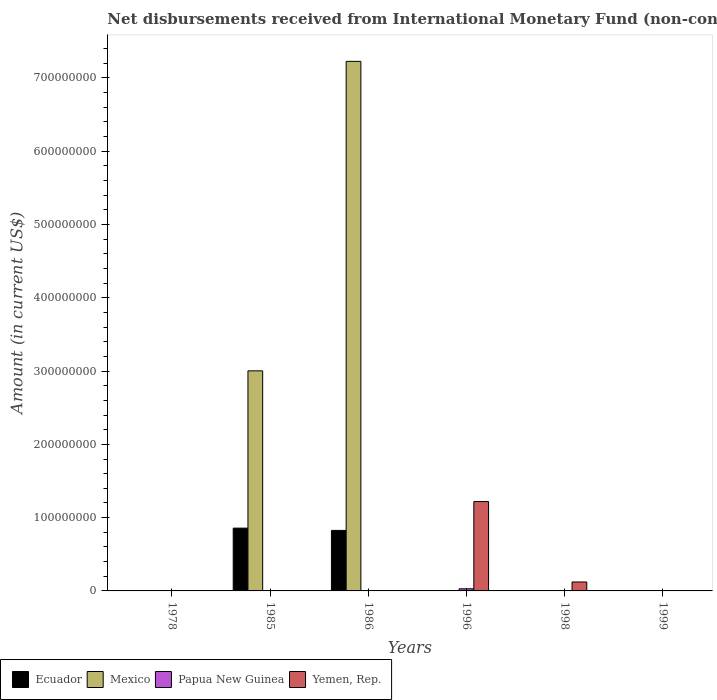How many different coloured bars are there?
Your answer should be very brief. 4. Are the number of bars per tick equal to the number of legend labels?
Make the answer very short. No. Are the number of bars on each tick of the X-axis equal?
Ensure brevity in your answer.  No. How many bars are there on the 4th tick from the left?
Give a very brief answer. 2. What is the label of the 2nd group of bars from the left?
Your response must be concise. 1985. What is the amount of disbursements received from International Monetary Fund in Yemen, Rep. in 1986?
Your answer should be very brief. 0. Across all years, what is the maximum amount of disbursements received from International Monetary Fund in Mexico?
Provide a short and direct response. 7.23e+08. Across all years, what is the minimum amount of disbursements received from International Monetary Fund in Papua New Guinea?
Provide a short and direct response. 0. What is the total amount of disbursements received from International Monetary Fund in Mexico in the graph?
Your answer should be very brief. 1.02e+09. What is the difference between the amount of disbursements received from International Monetary Fund in Ecuador in 1985 and that in 1986?
Offer a very short reply. 3.12e+06. What is the difference between the amount of disbursements received from International Monetary Fund in Papua New Guinea in 1998 and the amount of disbursements received from International Monetary Fund in Yemen, Rep. in 1996?
Your answer should be compact. -1.22e+08. What is the average amount of disbursements received from International Monetary Fund in Papua New Guinea per year?
Make the answer very short. 4.84e+05. In the year 1996, what is the difference between the amount of disbursements received from International Monetary Fund in Papua New Guinea and amount of disbursements received from International Monetary Fund in Yemen, Rep.?
Your response must be concise. -1.19e+08. What is the difference between the highest and the lowest amount of disbursements received from International Monetary Fund in Papua New Guinea?
Your answer should be very brief. 2.90e+06. In how many years, is the amount of disbursements received from International Monetary Fund in Papua New Guinea greater than the average amount of disbursements received from International Monetary Fund in Papua New Guinea taken over all years?
Give a very brief answer. 1. Is it the case that in every year, the sum of the amount of disbursements received from International Monetary Fund in Mexico and amount of disbursements received from International Monetary Fund in Ecuador is greater than the amount of disbursements received from International Monetary Fund in Papua New Guinea?
Keep it short and to the point. No. How many bars are there?
Your response must be concise. 7. How many years are there in the graph?
Make the answer very short. 6. What is the difference between two consecutive major ticks on the Y-axis?
Provide a short and direct response. 1.00e+08. Does the graph contain grids?
Give a very brief answer. No. Where does the legend appear in the graph?
Offer a very short reply. Bottom left. How many legend labels are there?
Your response must be concise. 4. What is the title of the graph?
Ensure brevity in your answer.  Net disbursements received from International Monetary Fund (non-concessional). Does "Netherlands" appear as one of the legend labels in the graph?
Provide a succinct answer. No. What is the Amount (in current US$) in Mexico in 1978?
Keep it short and to the point. 0. What is the Amount (in current US$) in Papua New Guinea in 1978?
Offer a very short reply. 0. What is the Amount (in current US$) in Ecuador in 1985?
Keep it short and to the point. 8.57e+07. What is the Amount (in current US$) in Mexico in 1985?
Provide a succinct answer. 3.00e+08. What is the Amount (in current US$) of Ecuador in 1986?
Give a very brief answer. 8.26e+07. What is the Amount (in current US$) of Mexico in 1986?
Provide a succinct answer. 7.23e+08. What is the Amount (in current US$) in Papua New Guinea in 1996?
Keep it short and to the point. 2.90e+06. What is the Amount (in current US$) of Yemen, Rep. in 1996?
Offer a terse response. 1.22e+08. What is the Amount (in current US$) of Mexico in 1998?
Your response must be concise. 0. What is the Amount (in current US$) in Yemen, Rep. in 1998?
Your response must be concise. 1.22e+07. What is the Amount (in current US$) in Ecuador in 1999?
Your answer should be very brief. 0. What is the Amount (in current US$) of Mexico in 1999?
Keep it short and to the point. 0. Across all years, what is the maximum Amount (in current US$) of Ecuador?
Provide a succinct answer. 8.57e+07. Across all years, what is the maximum Amount (in current US$) in Mexico?
Provide a succinct answer. 7.23e+08. Across all years, what is the maximum Amount (in current US$) of Papua New Guinea?
Offer a very short reply. 2.90e+06. Across all years, what is the maximum Amount (in current US$) of Yemen, Rep.?
Offer a very short reply. 1.22e+08. Across all years, what is the minimum Amount (in current US$) in Yemen, Rep.?
Your answer should be very brief. 0. What is the total Amount (in current US$) of Ecuador in the graph?
Provide a short and direct response. 1.68e+08. What is the total Amount (in current US$) of Mexico in the graph?
Your answer should be very brief. 1.02e+09. What is the total Amount (in current US$) in Papua New Guinea in the graph?
Your answer should be very brief. 2.90e+06. What is the total Amount (in current US$) of Yemen, Rep. in the graph?
Give a very brief answer. 1.34e+08. What is the difference between the Amount (in current US$) in Ecuador in 1985 and that in 1986?
Offer a very short reply. 3.12e+06. What is the difference between the Amount (in current US$) of Mexico in 1985 and that in 1986?
Offer a terse response. -4.22e+08. What is the difference between the Amount (in current US$) of Yemen, Rep. in 1996 and that in 1998?
Provide a succinct answer. 1.10e+08. What is the difference between the Amount (in current US$) of Ecuador in 1985 and the Amount (in current US$) of Mexico in 1986?
Your response must be concise. -6.37e+08. What is the difference between the Amount (in current US$) of Ecuador in 1985 and the Amount (in current US$) of Papua New Guinea in 1996?
Offer a terse response. 8.28e+07. What is the difference between the Amount (in current US$) in Ecuador in 1985 and the Amount (in current US$) in Yemen, Rep. in 1996?
Your response must be concise. -3.63e+07. What is the difference between the Amount (in current US$) of Mexico in 1985 and the Amount (in current US$) of Papua New Guinea in 1996?
Your answer should be very brief. 2.97e+08. What is the difference between the Amount (in current US$) in Mexico in 1985 and the Amount (in current US$) in Yemen, Rep. in 1996?
Your answer should be very brief. 1.78e+08. What is the difference between the Amount (in current US$) in Ecuador in 1985 and the Amount (in current US$) in Yemen, Rep. in 1998?
Offer a very short reply. 7.35e+07. What is the difference between the Amount (in current US$) in Mexico in 1985 and the Amount (in current US$) in Yemen, Rep. in 1998?
Your answer should be compact. 2.88e+08. What is the difference between the Amount (in current US$) of Ecuador in 1986 and the Amount (in current US$) of Papua New Guinea in 1996?
Offer a terse response. 7.97e+07. What is the difference between the Amount (in current US$) in Ecuador in 1986 and the Amount (in current US$) in Yemen, Rep. in 1996?
Offer a very short reply. -3.94e+07. What is the difference between the Amount (in current US$) of Mexico in 1986 and the Amount (in current US$) of Papua New Guinea in 1996?
Make the answer very short. 7.20e+08. What is the difference between the Amount (in current US$) in Mexico in 1986 and the Amount (in current US$) in Yemen, Rep. in 1996?
Your response must be concise. 6.01e+08. What is the difference between the Amount (in current US$) of Ecuador in 1986 and the Amount (in current US$) of Yemen, Rep. in 1998?
Your response must be concise. 7.04e+07. What is the difference between the Amount (in current US$) in Mexico in 1986 and the Amount (in current US$) in Yemen, Rep. in 1998?
Provide a succinct answer. 7.10e+08. What is the difference between the Amount (in current US$) in Papua New Guinea in 1996 and the Amount (in current US$) in Yemen, Rep. in 1998?
Your answer should be very brief. -9.31e+06. What is the average Amount (in current US$) in Ecuador per year?
Make the answer very short. 2.80e+07. What is the average Amount (in current US$) of Mexico per year?
Make the answer very short. 1.70e+08. What is the average Amount (in current US$) in Papua New Guinea per year?
Provide a short and direct response. 4.84e+05. What is the average Amount (in current US$) of Yemen, Rep. per year?
Ensure brevity in your answer.  2.24e+07. In the year 1985, what is the difference between the Amount (in current US$) of Ecuador and Amount (in current US$) of Mexico?
Provide a short and direct response. -2.15e+08. In the year 1986, what is the difference between the Amount (in current US$) in Ecuador and Amount (in current US$) in Mexico?
Offer a terse response. -6.40e+08. In the year 1996, what is the difference between the Amount (in current US$) of Papua New Guinea and Amount (in current US$) of Yemen, Rep.?
Make the answer very short. -1.19e+08. What is the ratio of the Amount (in current US$) of Ecuador in 1985 to that in 1986?
Give a very brief answer. 1.04. What is the ratio of the Amount (in current US$) of Mexico in 1985 to that in 1986?
Your response must be concise. 0.42. What is the ratio of the Amount (in current US$) in Yemen, Rep. in 1996 to that in 1998?
Your response must be concise. 9.99. What is the difference between the highest and the lowest Amount (in current US$) of Ecuador?
Provide a short and direct response. 8.57e+07. What is the difference between the highest and the lowest Amount (in current US$) of Mexico?
Give a very brief answer. 7.23e+08. What is the difference between the highest and the lowest Amount (in current US$) in Papua New Guinea?
Provide a short and direct response. 2.90e+06. What is the difference between the highest and the lowest Amount (in current US$) of Yemen, Rep.?
Your response must be concise. 1.22e+08. 